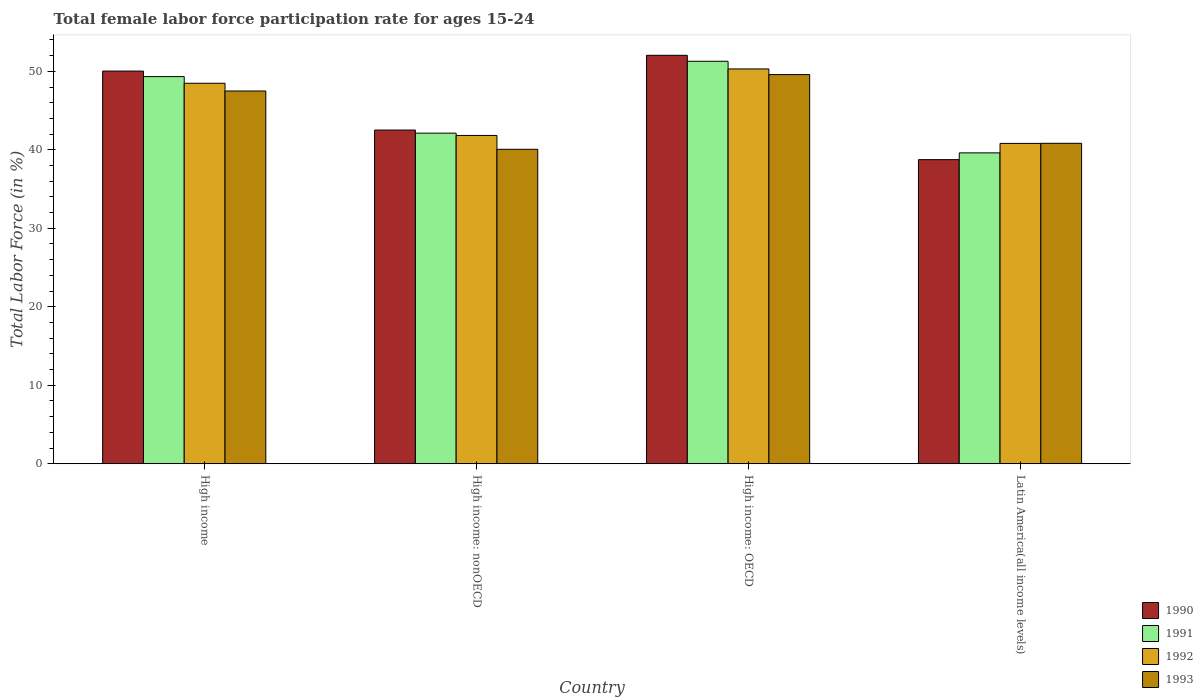How many different coloured bars are there?
Ensure brevity in your answer.  4. How many groups of bars are there?
Your response must be concise. 4. Are the number of bars on each tick of the X-axis equal?
Ensure brevity in your answer.  Yes. How many bars are there on the 4th tick from the right?
Your answer should be compact. 4. What is the label of the 2nd group of bars from the left?
Keep it short and to the point. High income: nonOECD. What is the female labor force participation rate in 1992 in High income: nonOECD?
Your answer should be compact. 41.83. Across all countries, what is the maximum female labor force participation rate in 1991?
Your answer should be very brief. 51.28. Across all countries, what is the minimum female labor force participation rate in 1992?
Offer a very short reply. 40.82. In which country was the female labor force participation rate in 1992 maximum?
Your response must be concise. High income: OECD. In which country was the female labor force participation rate in 1992 minimum?
Give a very brief answer. Latin America(all income levels). What is the total female labor force participation rate in 1993 in the graph?
Your response must be concise. 177.98. What is the difference between the female labor force participation rate in 1993 in High income and that in Latin America(all income levels)?
Give a very brief answer. 6.66. What is the difference between the female labor force participation rate in 1991 in Latin America(all income levels) and the female labor force participation rate in 1992 in High income?
Provide a short and direct response. -8.87. What is the average female labor force participation rate in 1990 per country?
Your response must be concise. 45.84. What is the difference between the female labor force participation rate of/in 1991 and female labor force participation rate of/in 1993 in High income: nonOECD?
Your answer should be very brief. 2.06. In how many countries, is the female labor force participation rate in 1990 greater than 26 %?
Your answer should be very brief. 4. What is the ratio of the female labor force participation rate in 1993 in High income: OECD to that in High income: nonOECD?
Ensure brevity in your answer.  1.24. Is the female labor force participation rate in 1992 in High income less than that in High income: OECD?
Offer a terse response. Yes. What is the difference between the highest and the second highest female labor force participation rate in 1993?
Make the answer very short. -8.76. What is the difference between the highest and the lowest female labor force participation rate in 1991?
Keep it short and to the point. 11.67. In how many countries, is the female labor force participation rate in 1991 greater than the average female labor force participation rate in 1991 taken over all countries?
Keep it short and to the point. 2. Is the sum of the female labor force participation rate in 1990 in High income: OECD and Latin America(all income levels) greater than the maximum female labor force participation rate in 1991 across all countries?
Offer a terse response. Yes. Is it the case that in every country, the sum of the female labor force participation rate in 1991 and female labor force participation rate in 1993 is greater than the sum of female labor force participation rate in 1990 and female labor force participation rate in 1992?
Your answer should be compact. No. What does the 1st bar from the left in Latin America(all income levels) represents?
Offer a very short reply. 1990. What does the 3rd bar from the right in High income: OECD represents?
Keep it short and to the point. 1991. Are all the bars in the graph horizontal?
Your response must be concise. No. How many countries are there in the graph?
Your response must be concise. 4. What is the difference between two consecutive major ticks on the Y-axis?
Keep it short and to the point. 10. Are the values on the major ticks of Y-axis written in scientific E-notation?
Keep it short and to the point. No. How are the legend labels stacked?
Make the answer very short. Vertical. What is the title of the graph?
Offer a very short reply. Total female labor force participation rate for ages 15-24. Does "2005" appear as one of the legend labels in the graph?
Offer a terse response. No. What is the Total Labor Force (in %) in 1990 in High income?
Your response must be concise. 50.03. What is the Total Labor Force (in %) in 1991 in High income?
Provide a short and direct response. 49.33. What is the Total Labor Force (in %) in 1992 in High income?
Provide a succinct answer. 48.48. What is the Total Labor Force (in %) in 1993 in High income?
Offer a terse response. 47.5. What is the Total Labor Force (in %) in 1990 in High income: nonOECD?
Make the answer very short. 42.52. What is the Total Labor Force (in %) of 1991 in High income: nonOECD?
Your answer should be very brief. 42.12. What is the Total Labor Force (in %) in 1992 in High income: nonOECD?
Your answer should be compact. 41.83. What is the Total Labor Force (in %) in 1993 in High income: nonOECD?
Offer a terse response. 40.07. What is the Total Labor Force (in %) of 1990 in High income: OECD?
Offer a terse response. 52.04. What is the Total Labor Force (in %) in 1991 in High income: OECD?
Provide a short and direct response. 51.28. What is the Total Labor Force (in %) of 1992 in High income: OECD?
Keep it short and to the point. 50.3. What is the Total Labor Force (in %) in 1993 in High income: OECD?
Provide a short and direct response. 49.59. What is the Total Labor Force (in %) of 1990 in Latin America(all income levels)?
Your answer should be very brief. 38.75. What is the Total Labor Force (in %) in 1991 in Latin America(all income levels)?
Your response must be concise. 39.61. What is the Total Labor Force (in %) in 1992 in Latin America(all income levels)?
Give a very brief answer. 40.82. What is the Total Labor Force (in %) of 1993 in Latin America(all income levels)?
Make the answer very short. 40.83. Across all countries, what is the maximum Total Labor Force (in %) in 1990?
Offer a very short reply. 52.04. Across all countries, what is the maximum Total Labor Force (in %) of 1991?
Your answer should be very brief. 51.28. Across all countries, what is the maximum Total Labor Force (in %) of 1992?
Your answer should be very brief. 50.3. Across all countries, what is the maximum Total Labor Force (in %) in 1993?
Ensure brevity in your answer.  49.59. Across all countries, what is the minimum Total Labor Force (in %) in 1990?
Keep it short and to the point. 38.75. Across all countries, what is the minimum Total Labor Force (in %) of 1991?
Your answer should be very brief. 39.61. Across all countries, what is the minimum Total Labor Force (in %) in 1992?
Ensure brevity in your answer.  40.82. Across all countries, what is the minimum Total Labor Force (in %) of 1993?
Provide a succinct answer. 40.07. What is the total Total Labor Force (in %) of 1990 in the graph?
Offer a terse response. 183.34. What is the total Total Labor Force (in %) of 1991 in the graph?
Offer a terse response. 182.35. What is the total Total Labor Force (in %) in 1992 in the graph?
Offer a terse response. 181.43. What is the total Total Labor Force (in %) in 1993 in the graph?
Give a very brief answer. 177.98. What is the difference between the Total Labor Force (in %) in 1990 in High income and that in High income: nonOECD?
Give a very brief answer. 7.52. What is the difference between the Total Labor Force (in %) in 1991 in High income and that in High income: nonOECD?
Offer a very short reply. 7.2. What is the difference between the Total Labor Force (in %) of 1992 in High income and that in High income: nonOECD?
Make the answer very short. 6.65. What is the difference between the Total Labor Force (in %) of 1993 in High income and that in High income: nonOECD?
Offer a terse response. 7.43. What is the difference between the Total Labor Force (in %) of 1990 in High income and that in High income: OECD?
Your response must be concise. -2.01. What is the difference between the Total Labor Force (in %) of 1991 in High income and that in High income: OECD?
Provide a succinct answer. -1.95. What is the difference between the Total Labor Force (in %) of 1992 in High income and that in High income: OECD?
Offer a terse response. -1.82. What is the difference between the Total Labor Force (in %) in 1993 in High income and that in High income: OECD?
Your answer should be compact. -2.09. What is the difference between the Total Labor Force (in %) in 1990 in High income and that in Latin America(all income levels)?
Give a very brief answer. 11.29. What is the difference between the Total Labor Force (in %) in 1991 in High income and that in Latin America(all income levels)?
Give a very brief answer. 9.72. What is the difference between the Total Labor Force (in %) of 1992 in High income and that in Latin America(all income levels)?
Ensure brevity in your answer.  7.67. What is the difference between the Total Labor Force (in %) in 1993 in High income and that in Latin America(all income levels)?
Keep it short and to the point. 6.66. What is the difference between the Total Labor Force (in %) of 1990 in High income: nonOECD and that in High income: OECD?
Make the answer very short. -9.53. What is the difference between the Total Labor Force (in %) of 1991 in High income: nonOECD and that in High income: OECD?
Offer a terse response. -9.16. What is the difference between the Total Labor Force (in %) of 1992 in High income: nonOECD and that in High income: OECD?
Keep it short and to the point. -8.47. What is the difference between the Total Labor Force (in %) of 1993 in High income: nonOECD and that in High income: OECD?
Give a very brief answer. -9.52. What is the difference between the Total Labor Force (in %) in 1990 in High income: nonOECD and that in Latin America(all income levels)?
Make the answer very short. 3.77. What is the difference between the Total Labor Force (in %) in 1991 in High income: nonOECD and that in Latin America(all income levels)?
Keep it short and to the point. 2.51. What is the difference between the Total Labor Force (in %) in 1992 in High income: nonOECD and that in Latin America(all income levels)?
Your response must be concise. 1.02. What is the difference between the Total Labor Force (in %) in 1993 in High income: nonOECD and that in Latin America(all income levels)?
Your answer should be compact. -0.76. What is the difference between the Total Labor Force (in %) of 1990 in High income: OECD and that in Latin America(all income levels)?
Provide a short and direct response. 13.3. What is the difference between the Total Labor Force (in %) in 1991 in High income: OECD and that in Latin America(all income levels)?
Offer a terse response. 11.67. What is the difference between the Total Labor Force (in %) in 1992 in High income: OECD and that in Latin America(all income levels)?
Keep it short and to the point. 9.49. What is the difference between the Total Labor Force (in %) of 1993 in High income: OECD and that in Latin America(all income levels)?
Give a very brief answer. 8.76. What is the difference between the Total Labor Force (in %) in 1990 in High income and the Total Labor Force (in %) in 1991 in High income: nonOECD?
Offer a terse response. 7.91. What is the difference between the Total Labor Force (in %) of 1990 in High income and the Total Labor Force (in %) of 1992 in High income: nonOECD?
Make the answer very short. 8.2. What is the difference between the Total Labor Force (in %) in 1990 in High income and the Total Labor Force (in %) in 1993 in High income: nonOECD?
Provide a succinct answer. 9.97. What is the difference between the Total Labor Force (in %) of 1991 in High income and the Total Labor Force (in %) of 1992 in High income: nonOECD?
Your response must be concise. 7.5. What is the difference between the Total Labor Force (in %) in 1991 in High income and the Total Labor Force (in %) in 1993 in High income: nonOECD?
Provide a succinct answer. 9.26. What is the difference between the Total Labor Force (in %) in 1992 in High income and the Total Labor Force (in %) in 1993 in High income: nonOECD?
Your answer should be compact. 8.42. What is the difference between the Total Labor Force (in %) in 1990 in High income and the Total Labor Force (in %) in 1991 in High income: OECD?
Offer a very short reply. -1.25. What is the difference between the Total Labor Force (in %) of 1990 in High income and the Total Labor Force (in %) of 1992 in High income: OECD?
Your response must be concise. -0.27. What is the difference between the Total Labor Force (in %) in 1990 in High income and the Total Labor Force (in %) in 1993 in High income: OECD?
Give a very brief answer. 0.45. What is the difference between the Total Labor Force (in %) in 1991 in High income and the Total Labor Force (in %) in 1992 in High income: OECD?
Provide a short and direct response. -0.98. What is the difference between the Total Labor Force (in %) in 1991 in High income and the Total Labor Force (in %) in 1993 in High income: OECD?
Give a very brief answer. -0.26. What is the difference between the Total Labor Force (in %) of 1992 in High income and the Total Labor Force (in %) of 1993 in High income: OECD?
Your answer should be compact. -1.1. What is the difference between the Total Labor Force (in %) in 1990 in High income and the Total Labor Force (in %) in 1991 in Latin America(all income levels)?
Your answer should be compact. 10.42. What is the difference between the Total Labor Force (in %) of 1990 in High income and the Total Labor Force (in %) of 1992 in Latin America(all income levels)?
Keep it short and to the point. 9.22. What is the difference between the Total Labor Force (in %) in 1990 in High income and the Total Labor Force (in %) in 1993 in Latin America(all income levels)?
Provide a short and direct response. 9.2. What is the difference between the Total Labor Force (in %) in 1991 in High income and the Total Labor Force (in %) in 1992 in Latin America(all income levels)?
Make the answer very short. 8.51. What is the difference between the Total Labor Force (in %) in 1991 in High income and the Total Labor Force (in %) in 1993 in Latin America(all income levels)?
Offer a very short reply. 8.5. What is the difference between the Total Labor Force (in %) of 1992 in High income and the Total Labor Force (in %) of 1993 in Latin America(all income levels)?
Offer a terse response. 7.65. What is the difference between the Total Labor Force (in %) in 1990 in High income: nonOECD and the Total Labor Force (in %) in 1991 in High income: OECD?
Your answer should be very brief. -8.76. What is the difference between the Total Labor Force (in %) in 1990 in High income: nonOECD and the Total Labor Force (in %) in 1992 in High income: OECD?
Make the answer very short. -7.79. What is the difference between the Total Labor Force (in %) of 1990 in High income: nonOECD and the Total Labor Force (in %) of 1993 in High income: OECD?
Provide a succinct answer. -7.07. What is the difference between the Total Labor Force (in %) in 1991 in High income: nonOECD and the Total Labor Force (in %) in 1992 in High income: OECD?
Give a very brief answer. -8.18. What is the difference between the Total Labor Force (in %) of 1991 in High income: nonOECD and the Total Labor Force (in %) of 1993 in High income: OECD?
Give a very brief answer. -7.46. What is the difference between the Total Labor Force (in %) in 1992 in High income: nonOECD and the Total Labor Force (in %) in 1993 in High income: OECD?
Your answer should be very brief. -7.75. What is the difference between the Total Labor Force (in %) in 1990 in High income: nonOECD and the Total Labor Force (in %) in 1991 in Latin America(all income levels)?
Provide a short and direct response. 2.91. What is the difference between the Total Labor Force (in %) in 1990 in High income: nonOECD and the Total Labor Force (in %) in 1992 in Latin America(all income levels)?
Ensure brevity in your answer.  1.7. What is the difference between the Total Labor Force (in %) of 1990 in High income: nonOECD and the Total Labor Force (in %) of 1993 in Latin America(all income levels)?
Keep it short and to the point. 1.69. What is the difference between the Total Labor Force (in %) in 1991 in High income: nonOECD and the Total Labor Force (in %) in 1992 in Latin America(all income levels)?
Offer a very short reply. 1.31. What is the difference between the Total Labor Force (in %) of 1991 in High income: nonOECD and the Total Labor Force (in %) of 1993 in Latin America(all income levels)?
Your answer should be very brief. 1.29. What is the difference between the Total Labor Force (in %) in 1990 in High income: OECD and the Total Labor Force (in %) in 1991 in Latin America(all income levels)?
Ensure brevity in your answer.  12.43. What is the difference between the Total Labor Force (in %) of 1990 in High income: OECD and the Total Labor Force (in %) of 1992 in Latin America(all income levels)?
Your answer should be very brief. 11.23. What is the difference between the Total Labor Force (in %) of 1990 in High income: OECD and the Total Labor Force (in %) of 1993 in Latin America(all income levels)?
Keep it short and to the point. 11.21. What is the difference between the Total Labor Force (in %) in 1991 in High income: OECD and the Total Labor Force (in %) in 1992 in Latin America(all income levels)?
Your answer should be compact. 10.47. What is the difference between the Total Labor Force (in %) in 1991 in High income: OECD and the Total Labor Force (in %) in 1993 in Latin America(all income levels)?
Make the answer very short. 10.45. What is the difference between the Total Labor Force (in %) in 1992 in High income: OECD and the Total Labor Force (in %) in 1993 in Latin America(all income levels)?
Make the answer very short. 9.47. What is the average Total Labor Force (in %) in 1990 per country?
Your answer should be very brief. 45.84. What is the average Total Labor Force (in %) in 1991 per country?
Keep it short and to the point. 45.59. What is the average Total Labor Force (in %) in 1992 per country?
Offer a very short reply. 45.36. What is the average Total Labor Force (in %) of 1993 per country?
Make the answer very short. 44.49. What is the difference between the Total Labor Force (in %) in 1990 and Total Labor Force (in %) in 1991 in High income?
Give a very brief answer. 0.71. What is the difference between the Total Labor Force (in %) of 1990 and Total Labor Force (in %) of 1992 in High income?
Provide a succinct answer. 1.55. What is the difference between the Total Labor Force (in %) in 1990 and Total Labor Force (in %) in 1993 in High income?
Provide a succinct answer. 2.54. What is the difference between the Total Labor Force (in %) in 1991 and Total Labor Force (in %) in 1992 in High income?
Give a very brief answer. 0.85. What is the difference between the Total Labor Force (in %) of 1991 and Total Labor Force (in %) of 1993 in High income?
Offer a very short reply. 1.83. What is the difference between the Total Labor Force (in %) of 1992 and Total Labor Force (in %) of 1993 in High income?
Make the answer very short. 0.99. What is the difference between the Total Labor Force (in %) in 1990 and Total Labor Force (in %) in 1991 in High income: nonOECD?
Offer a terse response. 0.39. What is the difference between the Total Labor Force (in %) in 1990 and Total Labor Force (in %) in 1992 in High income: nonOECD?
Your answer should be compact. 0.69. What is the difference between the Total Labor Force (in %) in 1990 and Total Labor Force (in %) in 1993 in High income: nonOECD?
Make the answer very short. 2.45. What is the difference between the Total Labor Force (in %) in 1991 and Total Labor Force (in %) in 1992 in High income: nonOECD?
Your answer should be very brief. 0.29. What is the difference between the Total Labor Force (in %) in 1991 and Total Labor Force (in %) in 1993 in High income: nonOECD?
Provide a short and direct response. 2.06. What is the difference between the Total Labor Force (in %) in 1992 and Total Labor Force (in %) in 1993 in High income: nonOECD?
Keep it short and to the point. 1.77. What is the difference between the Total Labor Force (in %) in 1990 and Total Labor Force (in %) in 1991 in High income: OECD?
Provide a short and direct response. 0.76. What is the difference between the Total Labor Force (in %) in 1990 and Total Labor Force (in %) in 1992 in High income: OECD?
Ensure brevity in your answer.  1.74. What is the difference between the Total Labor Force (in %) of 1990 and Total Labor Force (in %) of 1993 in High income: OECD?
Provide a short and direct response. 2.46. What is the difference between the Total Labor Force (in %) in 1991 and Total Labor Force (in %) in 1992 in High income: OECD?
Provide a succinct answer. 0.98. What is the difference between the Total Labor Force (in %) in 1991 and Total Labor Force (in %) in 1993 in High income: OECD?
Your answer should be compact. 1.7. What is the difference between the Total Labor Force (in %) of 1992 and Total Labor Force (in %) of 1993 in High income: OECD?
Make the answer very short. 0.72. What is the difference between the Total Labor Force (in %) of 1990 and Total Labor Force (in %) of 1991 in Latin America(all income levels)?
Make the answer very short. -0.86. What is the difference between the Total Labor Force (in %) of 1990 and Total Labor Force (in %) of 1992 in Latin America(all income levels)?
Your answer should be very brief. -2.07. What is the difference between the Total Labor Force (in %) of 1990 and Total Labor Force (in %) of 1993 in Latin America(all income levels)?
Keep it short and to the point. -2.08. What is the difference between the Total Labor Force (in %) in 1991 and Total Labor Force (in %) in 1992 in Latin America(all income levels)?
Your answer should be compact. -1.2. What is the difference between the Total Labor Force (in %) in 1991 and Total Labor Force (in %) in 1993 in Latin America(all income levels)?
Give a very brief answer. -1.22. What is the difference between the Total Labor Force (in %) of 1992 and Total Labor Force (in %) of 1993 in Latin America(all income levels)?
Provide a succinct answer. -0.02. What is the ratio of the Total Labor Force (in %) in 1990 in High income to that in High income: nonOECD?
Make the answer very short. 1.18. What is the ratio of the Total Labor Force (in %) in 1991 in High income to that in High income: nonOECD?
Offer a very short reply. 1.17. What is the ratio of the Total Labor Force (in %) of 1992 in High income to that in High income: nonOECD?
Provide a short and direct response. 1.16. What is the ratio of the Total Labor Force (in %) in 1993 in High income to that in High income: nonOECD?
Your answer should be compact. 1.19. What is the ratio of the Total Labor Force (in %) in 1990 in High income to that in High income: OECD?
Offer a terse response. 0.96. What is the ratio of the Total Labor Force (in %) of 1991 in High income to that in High income: OECD?
Give a very brief answer. 0.96. What is the ratio of the Total Labor Force (in %) in 1992 in High income to that in High income: OECD?
Give a very brief answer. 0.96. What is the ratio of the Total Labor Force (in %) of 1993 in High income to that in High income: OECD?
Provide a short and direct response. 0.96. What is the ratio of the Total Labor Force (in %) of 1990 in High income to that in Latin America(all income levels)?
Your answer should be very brief. 1.29. What is the ratio of the Total Labor Force (in %) in 1991 in High income to that in Latin America(all income levels)?
Provide a succinct answer. 1.25. What is the ratio of the Total Labor Force (in %) in 1992 in High income to that in Latin America(all income levels)?
Your answer should be compact. 1.19. What is the ratio of the Total Labor Force (in %) in 1993 in High income to that in Latin America(all income levels)?
Your response must be concise. 1.16. What is the ratio of the Total Labor Force (in %) of 1990 in High income: nonOECD to that in High income: OECD?
Give a very brief answer. 0.82. What is the ratio of the Total Labor Force (in %) of 1991 in High income: nonOECD to that in High income: OECD?
Offer a terse response. 0.82. What is the ratio of the Total Labor Force (in %) of 1992 in High income: nonOECD to that in High income: OECD?
Provide a short and direct response. 0.83. What is the ratio of the Total Labor Force (in %) in 1993 in High income: nonOECD to that in High income: OECD?
Keep it short and to the point. 0.81. What is the ratio of the Total Labor Force (in %) of 1990 in High income: nonOECD to that in Latin America(all income levels)?
Offer a very short reply. 1.1. What is the ratio of the Total Labor Force (in %) of 1991 in High income: nonOECD to that in Latin America(all income levels)?
Your answer should be very brief. 1.06. What is the ratio of the Total Labor Force (in %) in 1992 in High income: nonOECD to that in Latin America(all income levels)?
Offer a terse response. 1.02. What is the ratio of the Total Labor Force (in %) in 1993 in High income: nonOECD to that in Latin America(all income levels)?
Provide a succinct answer. 0.98. What is the ratio of the Total Labor Force (in %) of 1990 in High income: OECD to that in Latin America(all income levels)?
Your response must be concise. 1.34. What is the ratio of the Total Labor Force (in %) of 1991 in High income: OECD to that in Latin America(all income levels)?
Offer a very short reply. 1.29. What is the ratio of the Total Labor Force (in %) of 1992 in High income: OECD to that in Latin America(all income levels)?
Your answer should be compact. 1.23. What is the ratio of the Total Labor Force (in %) of 1993 in High income: OECD to that in Latin America(all income levels)?
Provide a succinct answer. 1.21. What is the difference between the highest and the second highest Total Labor Force (in %) of 1990?
Offer a terse response. 2.01. What is the difference between the highest and the second highest Total Labor Force (in %) in 1991?
Offer a very short reply. 1.95. What is the difference between the highest and the second highest Total Labor Force (in %) in 1992?
Offer a terse response. 1.82. What is the difference between the highest and the second highest Total Labor Force (in %) of 1993?
Provide a short and direct response. 2.09. What is the difference between the highest and the lowest Total Labor Force (in %) of 1990?
Provide a succinct answer. 13.3. What is the difference between the highest and the lowest Total Labor Force (in %) of 1991?
Keep it short and to the point. 11.67. What is the difference between the highest and the lowest Total Labor Force (in %) of 1992?
Ensure brevity in your answer.  9.49. What is the difference between the highest and the lowest Total Labor Force (in %) in 1993?
Offer a very short reply. 9.52. 